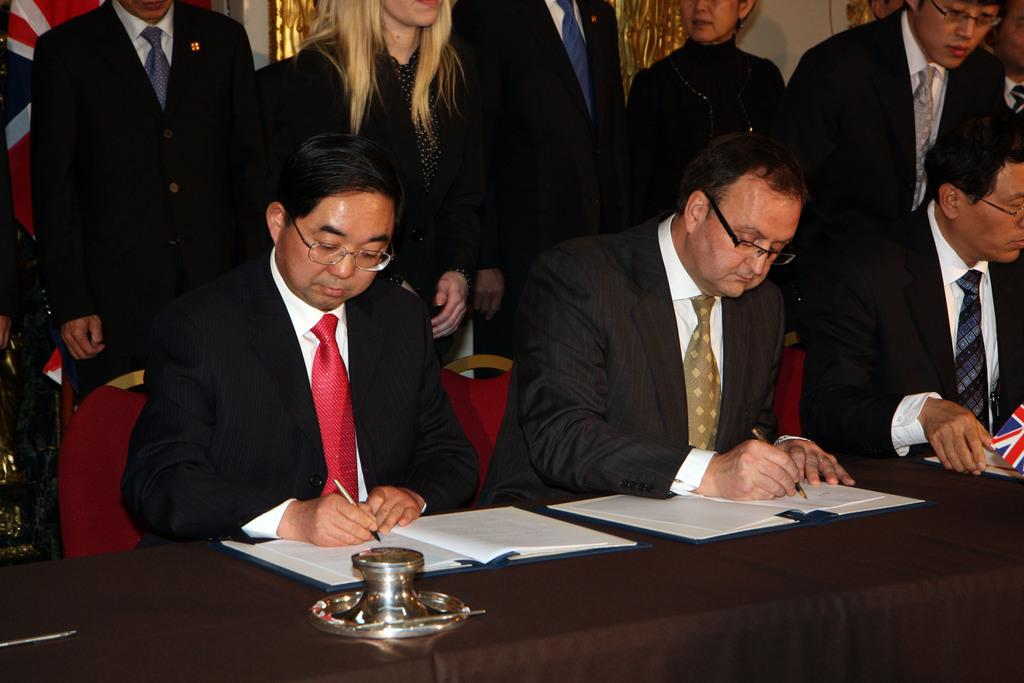What are the people in the image doing? The people in the image are sitting on chairs. Are there any other people visible in the image? Yes, there are people standing in the background of the image. What can be seen on the table in the image? There are objects on a table in the image. What is present in the background of the image besides the people standing? There is a flag in the background of the image. Can you see a kitty playing with a hydrant in the image? No, there is no kitty or hydrant present in the image. 